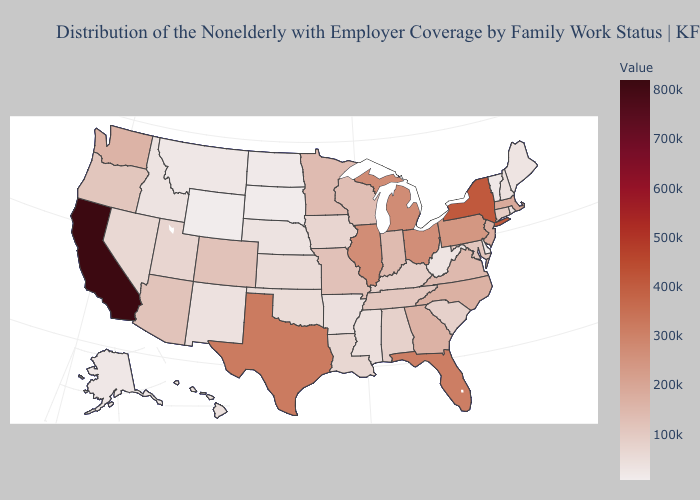Does the map have missing data?
Concise answer only. No. Which states hav the highest value in the Northeast?
Be succinct. New York. Does the map have missing data?
Short answer required. No. Does Minnesota have the lowest value in the USA?
Write a very short answer. No. 